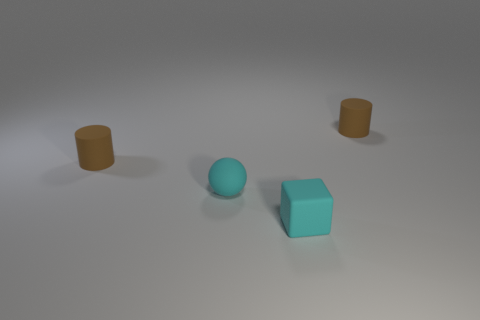Add 3 cubes. How many objects exist? 7 Subtract all blocks. How many objects are left? 3 Subtract all tiny blocks. Subtract all cyan things. How many objects are left? 1 Add 3 tiny rubber objects. How many tiny rubber objects are left? 7 Add 4 tiny brown matte things. How many tiny brown matte things exist? 6 Subtract 0 purple cubes. How many objects are left? 4 